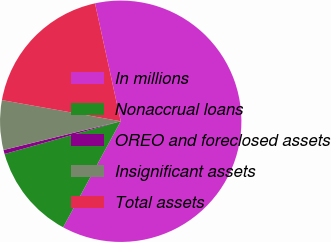Convert chart. <chart><loc_0><loc_0><loc_500><loc_500><pie_chart><fcel>In millions<fcel>Nonaccrual loans<fcel>OREO and foreclosed assets<fcel>Insignificant assets<fcel>Total assets<nl><fcel>61.34%<fcel>12.71%<fcel>0.55%<fcel>6.63%<fcel>18.78%<nl></chart> 